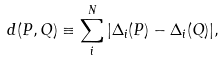Convert formula to latex. <formula><loc_0><loc_0><loc_500><loc_500>d ( P , Q ) \equiv \sum _ { i } ^ { N } | { \Delta } _ { i } ( P ) - { \Delta } _ { i } ( Q ) | ,</formula> 